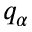Convert formula to latex. <formula><loc_0><loc_0><loc_500><loc_500>q _ { \alpha }</formula> 